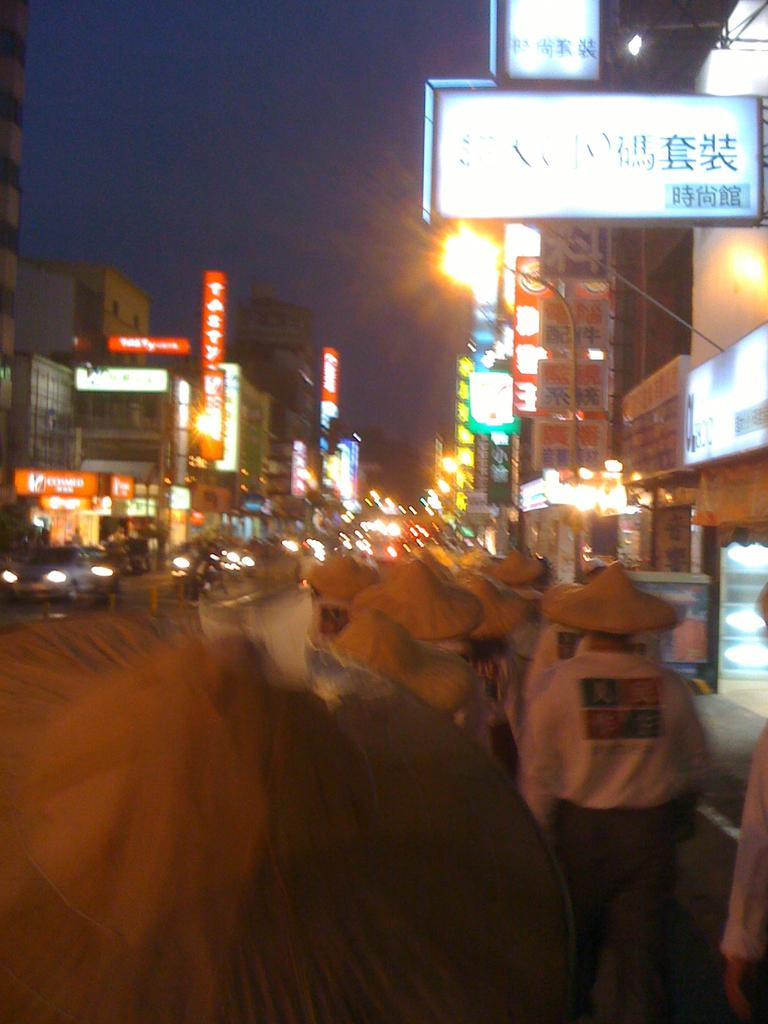What are the people in the image wearing on their heads? The people in the image are wearing hats. What can be seen in the background of the image? In the background of the image, there are lights, boards, and buildings. What is happening on the road in the image? Vehicles are visible on the road in the image. What is visible at the top of the image? The sky is visible at the top of the image. What type of seed is being planted in the image? There is no seed or planting activity present in the image. How does the kettle adjust the temperature in the image? There is no kettle present in the image. 